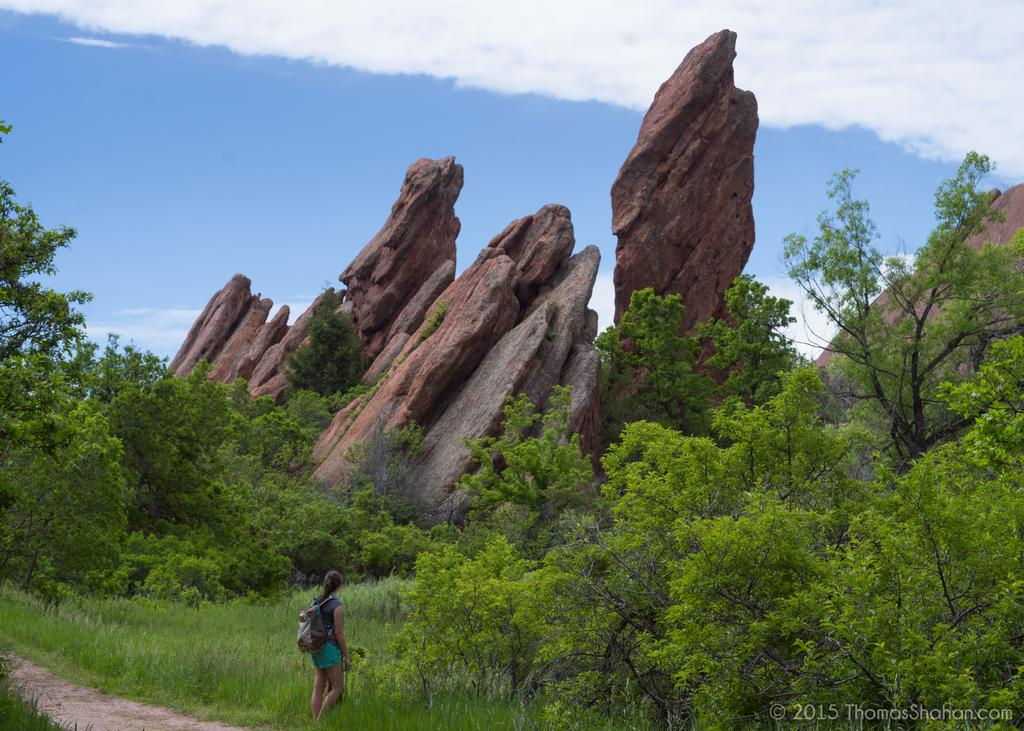What type of natural elements can be seen in the image? There are rocks and trees in the image. What is the person in the image standing on? The person is standing on the grass in the image. What is visible in the background of the image? The sky is visible in the image, and there are clouds in the sky. What type of drink is the person holding in the image? There is no drink visible in the image; the person is not holding anything. 